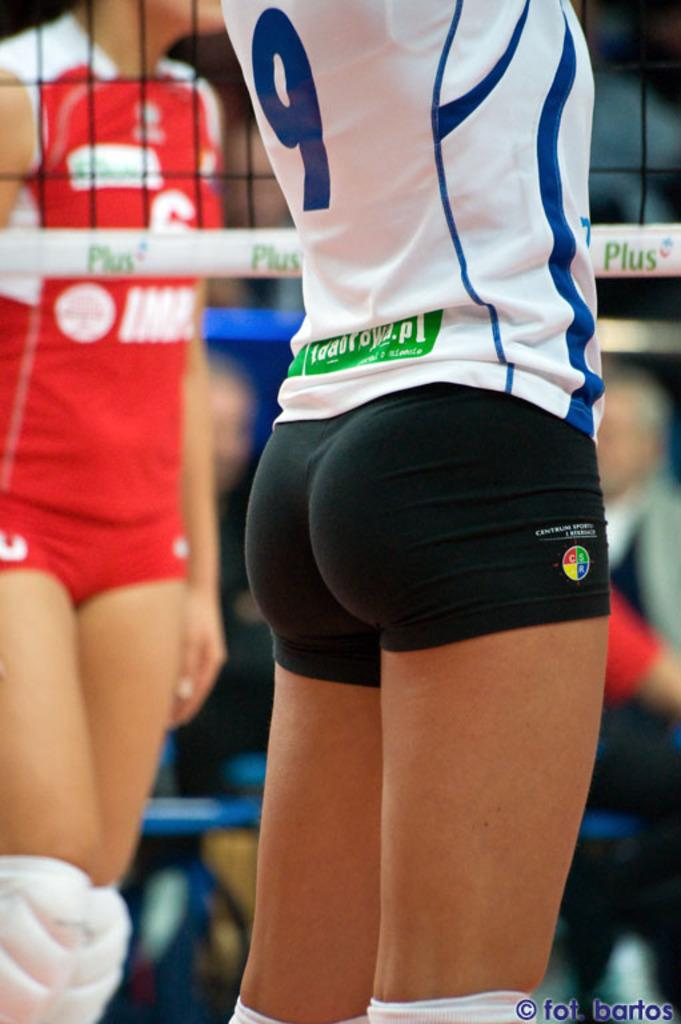Provide a one-sentence caption for the provided image. ladies volleyball game with a closeup on the butt of number 9. 